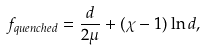<formula> <loc_0><loc_0><loc_500><loc_500>f _ { q u e n c h e d } = \frac { d } { 2 \mu } + ( \chi - 1 ) \ln d ,</formula> 